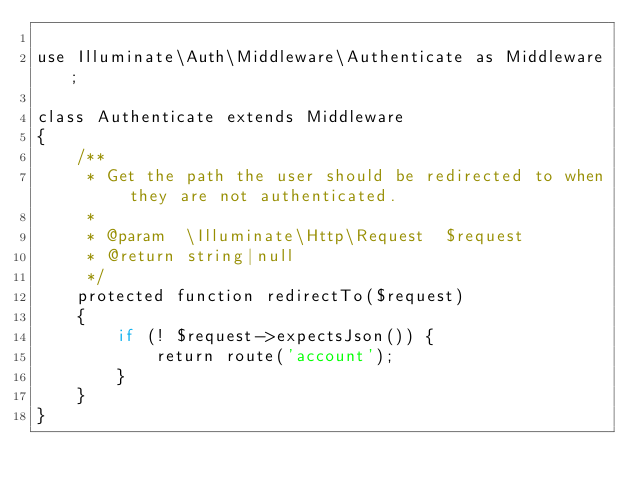Convert code to text. <code><loc_0><loc_0><loc_500><loc_500><_PHP_>
use Illuminate\Auth\Middleware\Authenticate as Middleware;

class Authenticate extends Middleware
{
    /**
     * Get the path the user should be redirected to when they are not authenticated.
     *
     * @param  \Illuminate\Http\Request  $request
     * @return string|null
     */
    protected function redirectTo($request)
    {
        if (! $request->expectsJson()) {
            return route('account');
        }
    }
}
</code> 